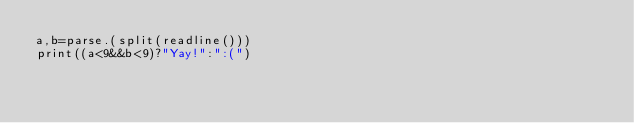<code> <loc_0><loc_0><loc_500><loc_500><_Julia_>a,b=parse.(split(readline()))
print((a<9&&b<9)?"Yay!":":(")</code> 